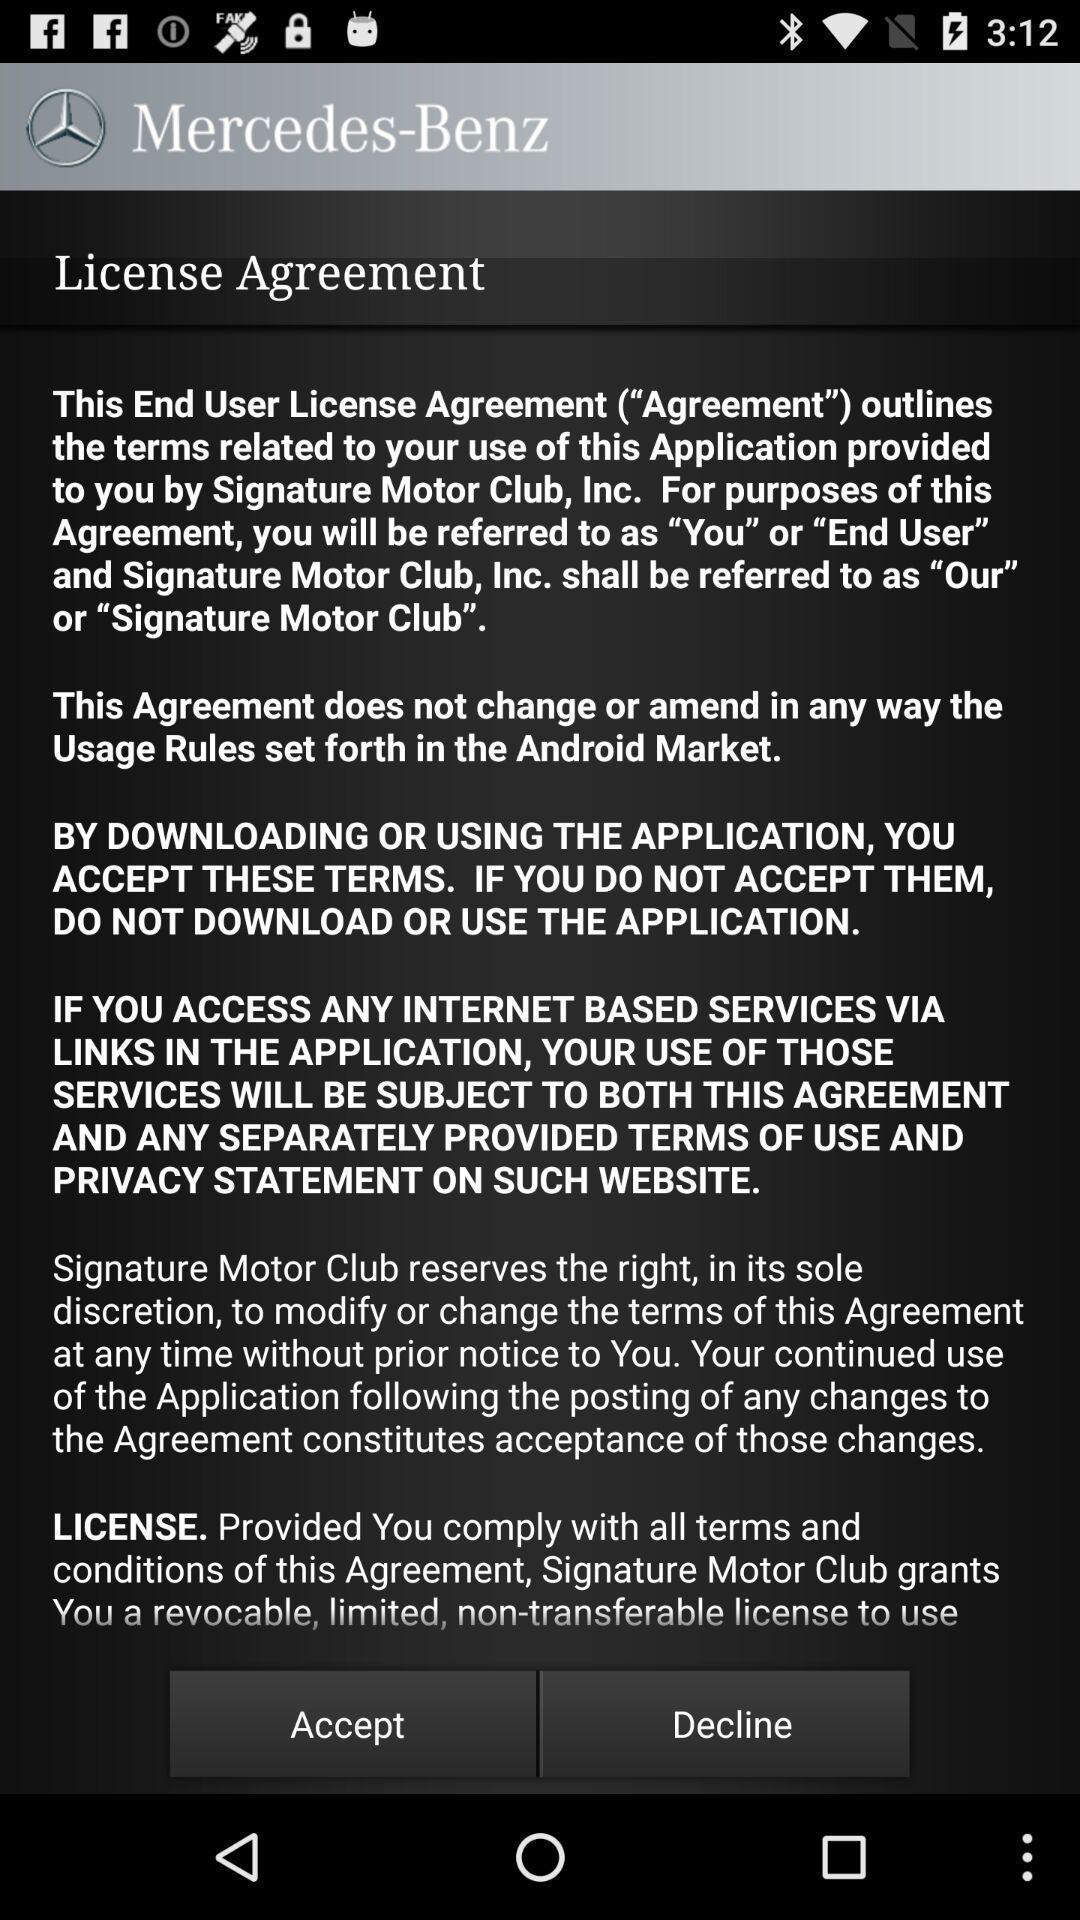Summarize the main components in this picture. Page shows terms and conditions for the motor vehicle app. 